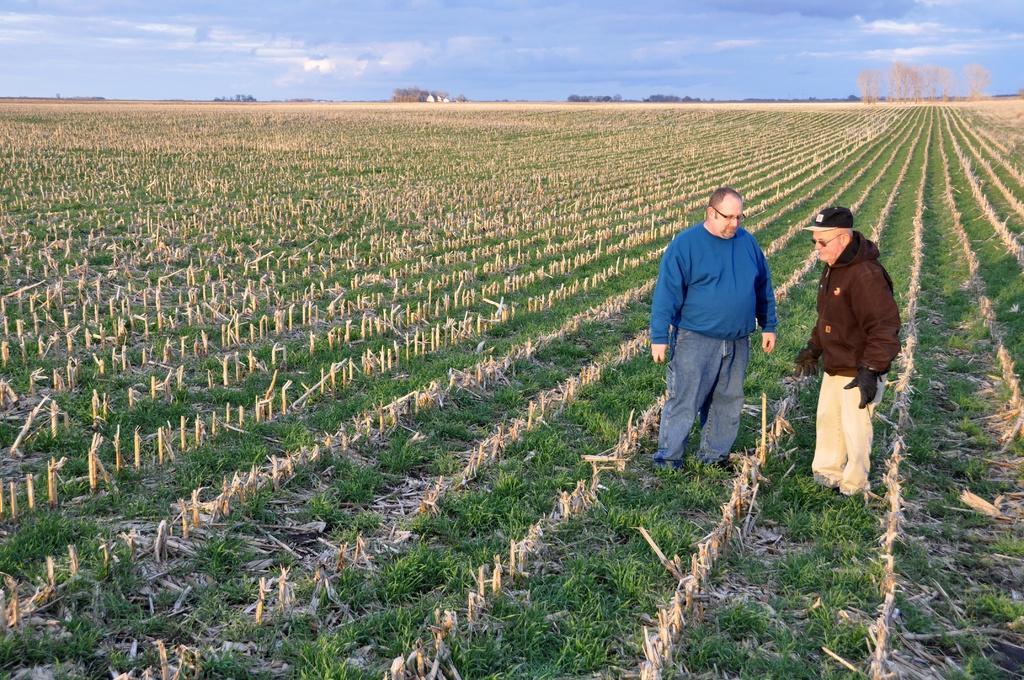Could you give a brief overview of what you see in this image? In this image on the right side two persons are standing on the ground and it looks like a field and we can see grass on the ground. In the background there are trees and clouds in the sky. 